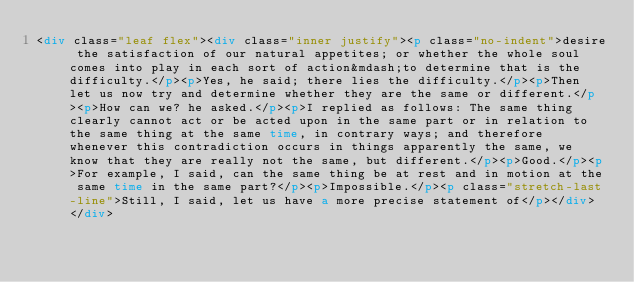<code> <loc_0><loc_0><loc_500><loc_500><_HTML_><div class="leaf flex"><div class="inner justify"><p class="no-indent">desire the satisfaction of our natural appetites; or whether the whole soul comes into play in each sort of action&mdash;to determine that is the difficulty.</p><p>Yes, he said; there lies the difficulty.</p><p>Then let us now try and determine whether they are the same or different.</p><p>How can we? he asked.</p><p>I replied as follows: The same thing clearly cannot act or be acted upon in the same part or in relation to the same thing at the same time, in contrary ways; and therefore whenever this contradiction occurs in things apparently the same, we know that they are really not the same, but different.</p><p>Good.</p><p>For example, I said, can the same thing be at rest and in motion at the same time in the same part?</p><p>Impossible.</p><p class="stretch-last-line">Still, I said, let us have a more precise statement of</p></div> </div></code> 